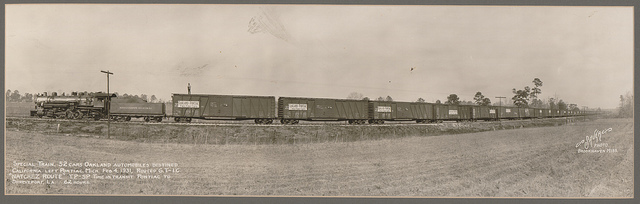<image>What do many of the pictures have in common? It is unknown what many of the pictures have in common. They could be related to trains or they could be black and white. Are there passengers on this train? It is unknown if there are passengers on this train. But it's mostly seen as no. Are there passengers on this train? There are no passengers on this train. It is unknown if there are any. What do many of the pictures have in common? I am not sure what many of the pictures have in common. It can be seen '4 corners', 'train', 'old', 'black and white'. 